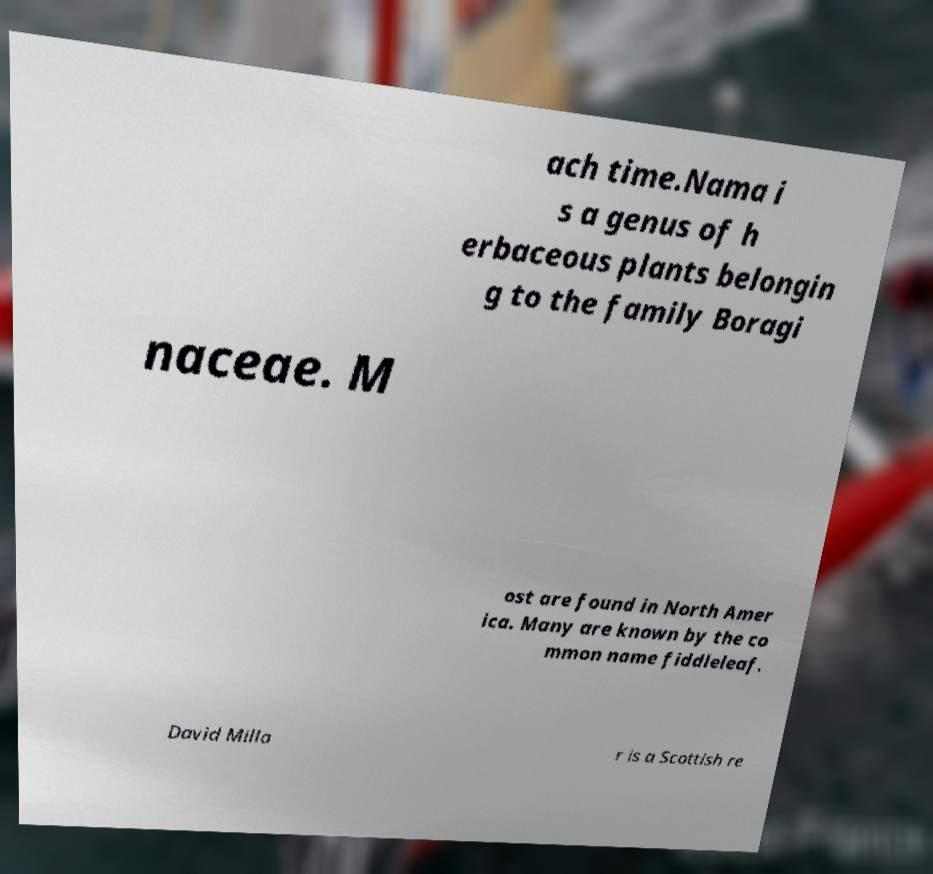Please identify and transcribe the text found in this image. ach time.Nama i s a genus of h erbaceous plants belongin g to the family Boragi naceae. M ost are found in North Amer ica. Many are known by the co mmon name fiddleleaf. David Milla r is a Scottish re 